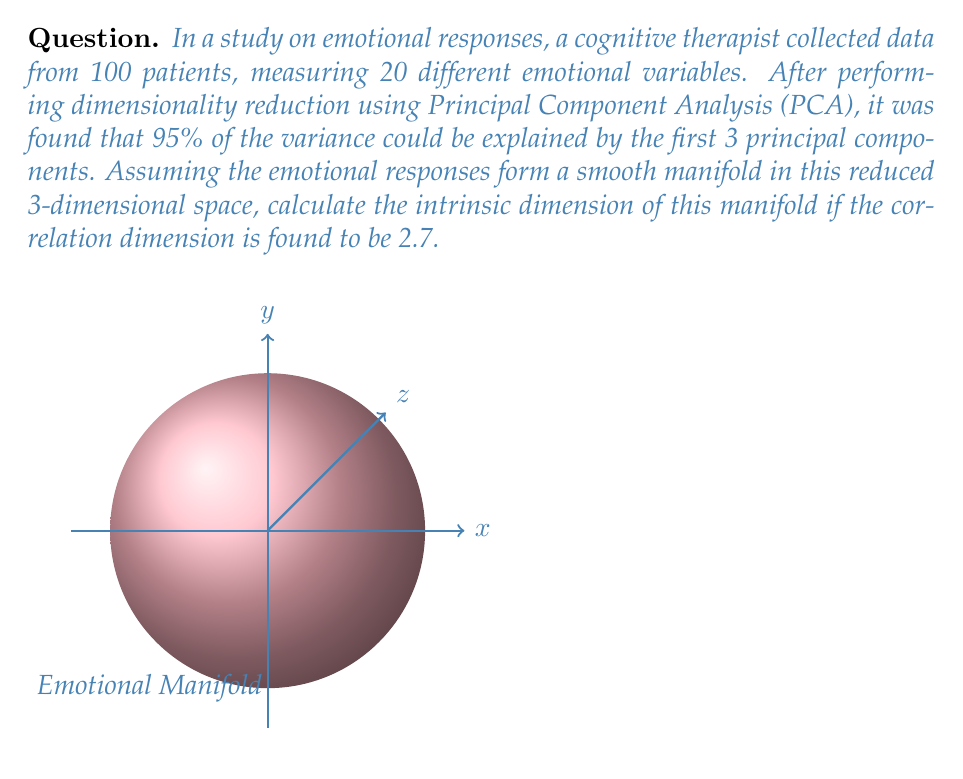What is the answer to this math problem? To solve this problem, we need to understand the concept of intrinsic dimension and its relation to the correlation dimension. Let's break it down step-by-step:

1) The intrinsic dimension of a manifold is the minimum number of parameters needed to describe a point on the manifold. It's often not an integer.

2) The correlation dimension is a measure of the dimensionality of the space occupied by a set of random points. It's related to the intrinsic dimension but is typically a fractional value.

3) For many types of attractors and manifolds, the intrinsic dimension (D) is approximately equal to the nearest integer greater than or equal to the correlation dimension (d).

4) Mathematically, this relationship can be expressed as:

   $$D \approx \lceil d \rceil$$

   where $\lceil \cdot \rceil$ denotes the ceiling function.

5) In this case, we're given that the correlation dimension d = 2.7.

6) Applying the ceiling function:

   $$D \approx \lceil 2.7 \rceil = 3$$

7) Therefore, the intrinsic dimension of the emotional response manifold is approximately 3.

This result suggests that despite the high-dimensional nature of the original data (20 variables), the emotional responses can be effectively described using just 3 parameters in the reduced space, aligning with the PCA results that showed 3 principal components explaining 95% of the variance.
Answer: 3 